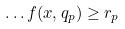<formula> <loc_0><loc_0><loc_500><loc_500>\dots f ( x , q _ { p } ) \geq r _ { p }</formula> 